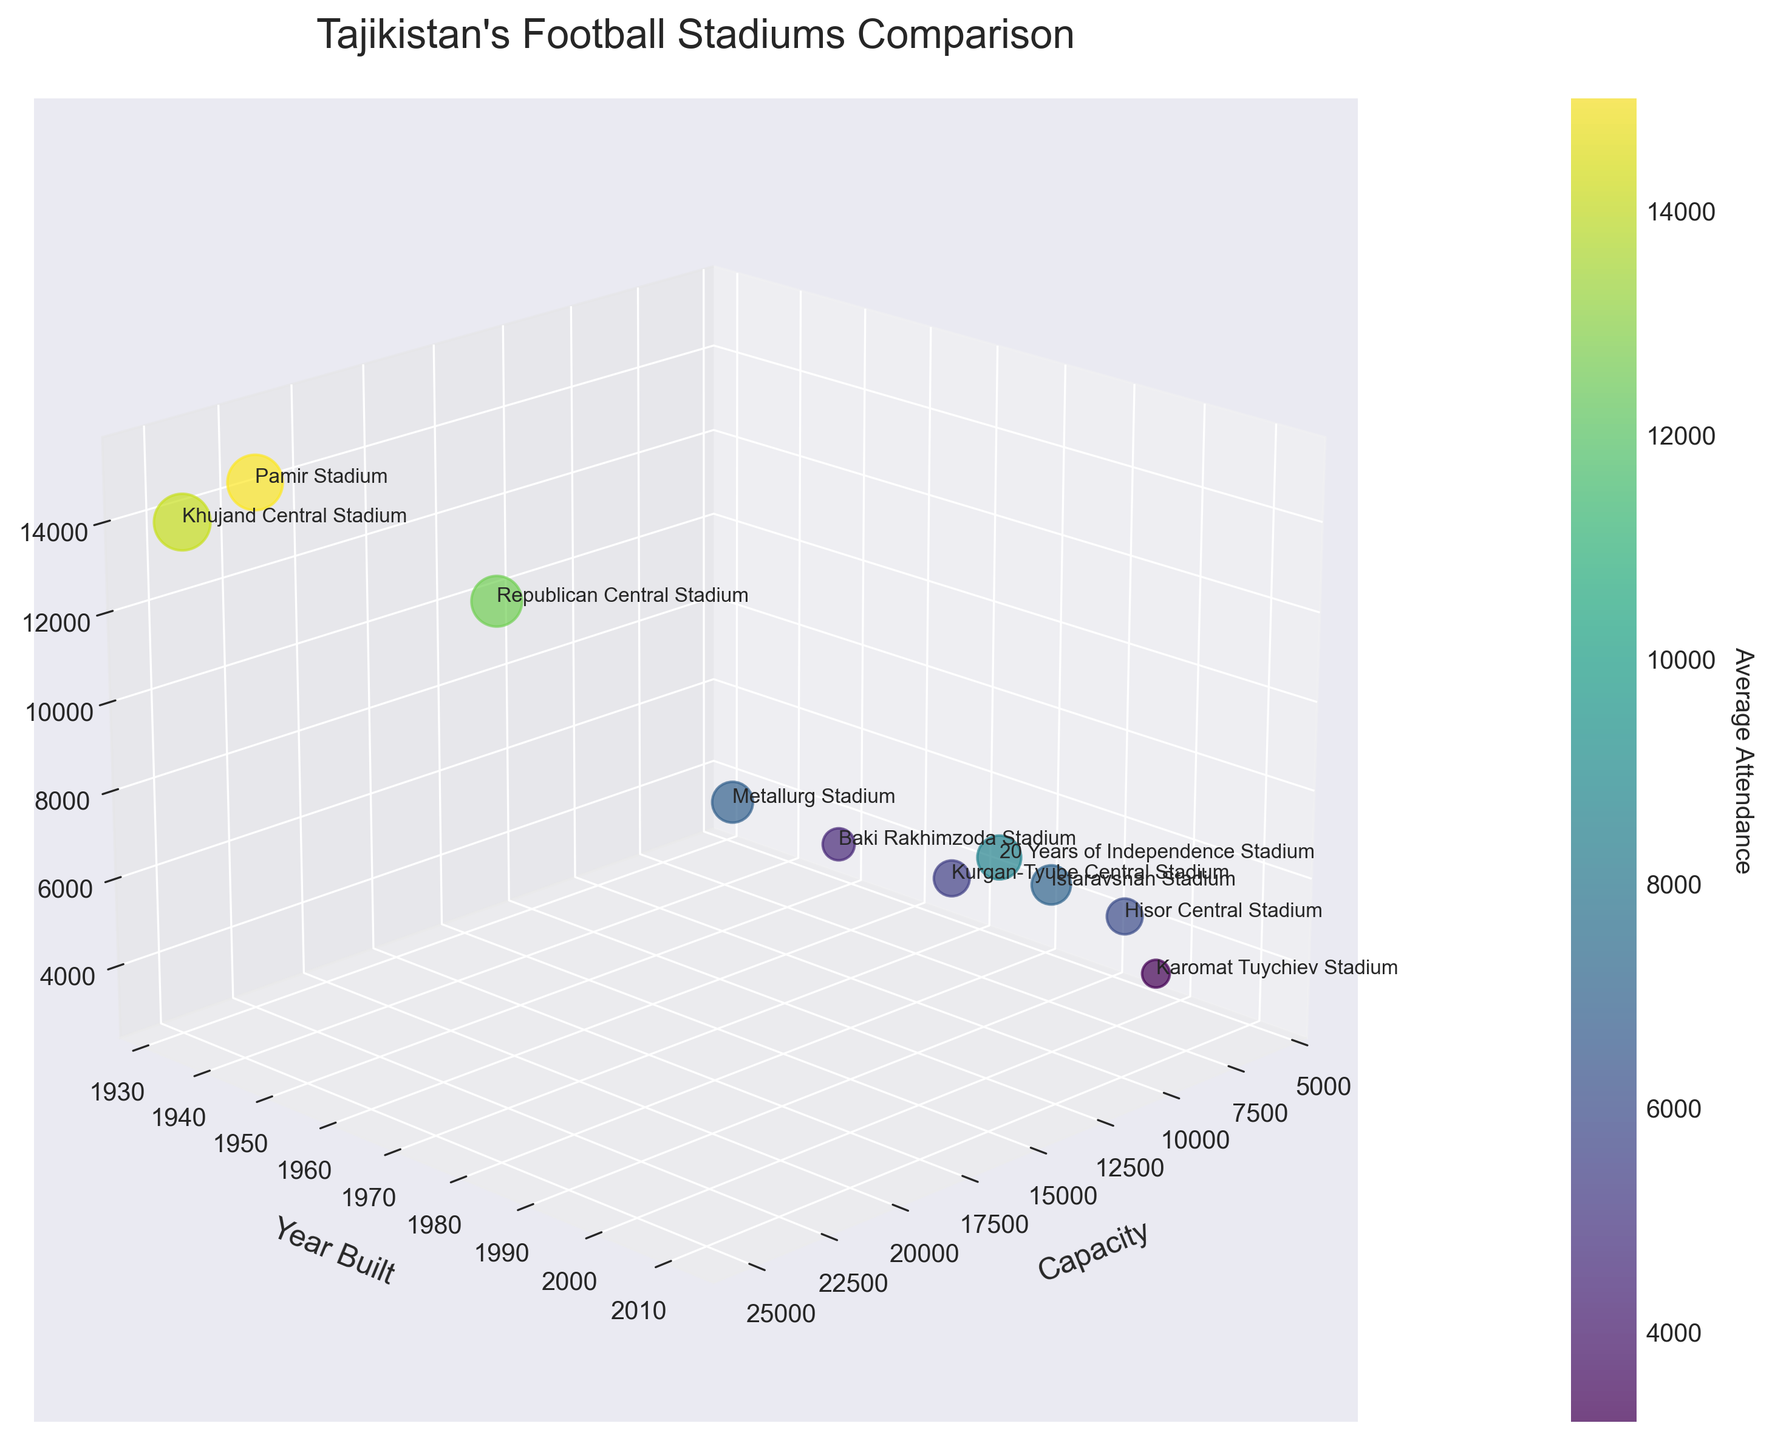What is the title of the figure? The title is typically found at the top of the figure, providing an overview of the content represented in the plot.
Answer: "Tajikistan's Football Stadiums Comparison" Which axis represents the 'Capacity' of the stadiums? The labels on the axes indicate what each axis represents. The x-axis label reads 'Capacity'.
Answer: x-axis How many stadiums have a capacity greater than 20,000? Locate the data points that are above 20,000 on the capacity axis (x-axis). There are 3 such stadiums.
Answer: 3 Which stadium was built most recently? Examine the y-axis labeled 'Year Built' and find the highest value indicating the most recent year.
Answer: 20 Years of Independence Stadium Which stadium has the highest average attendance? Identify the data point with the highest value on the z-axis labeled 'Average Attendance'.
Answer: Pamir Stadium Among the top 3 stadiums in capacity, which has the lowest average attendance? First, identify the top 3 stadiums by capacity on the x-axis. Then compare their 'Average Attendance' on the z-axis.
Answer: Khujand Central Stadium Does a higher capacity generally correlate with higher average attendance? Look for general trends or patterns where larger x-axis values correspond to larger z-axis values.
Answer: Yes What is the color range in the colorbar representing? Refer to the colorbar added next to the plot. It indicates the range of 'Average Attendance' values.
Answer: Average Attendance Which stadium has the smallest bubble size and why? Bubble size represents the normalized capacity. The smallest bubble indicates the stadium with the smallest capacity.
Answer: Karomat Tuychiev Stadium Is there a distinct clustering of stadiums built before 1960? Observe the distribution of data points along the y-axis for years before 1960 and note any distinct grouping.
Answer: Yes 